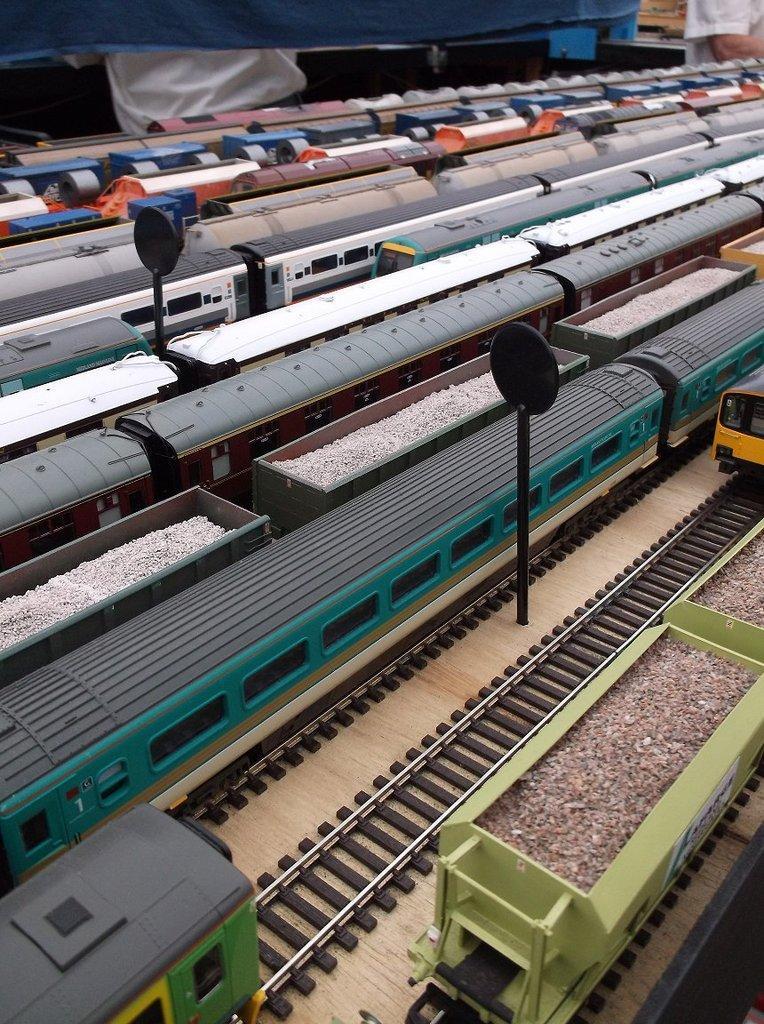How would you summarize this image in a sentence or two? It's a miniature, these are the trains and tracks. 